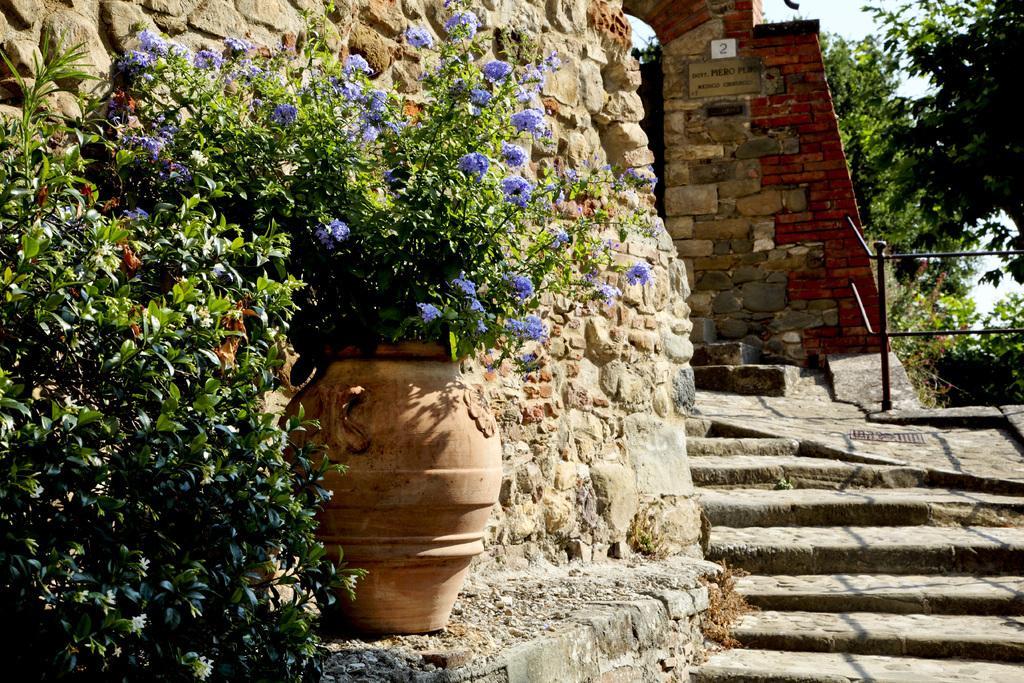Could you give a brief overview of what you see in this image? This picture shows trees and a monument and we see plants with flowers and a plant in the pot. 